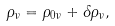Convert formula to latex. <formula><loc_0><loc_0><loc_500><loc_500>\rho _ { \nu } = \rho _ { 0 \nu } + \delta \rho _ { \nu } ,</formula> 